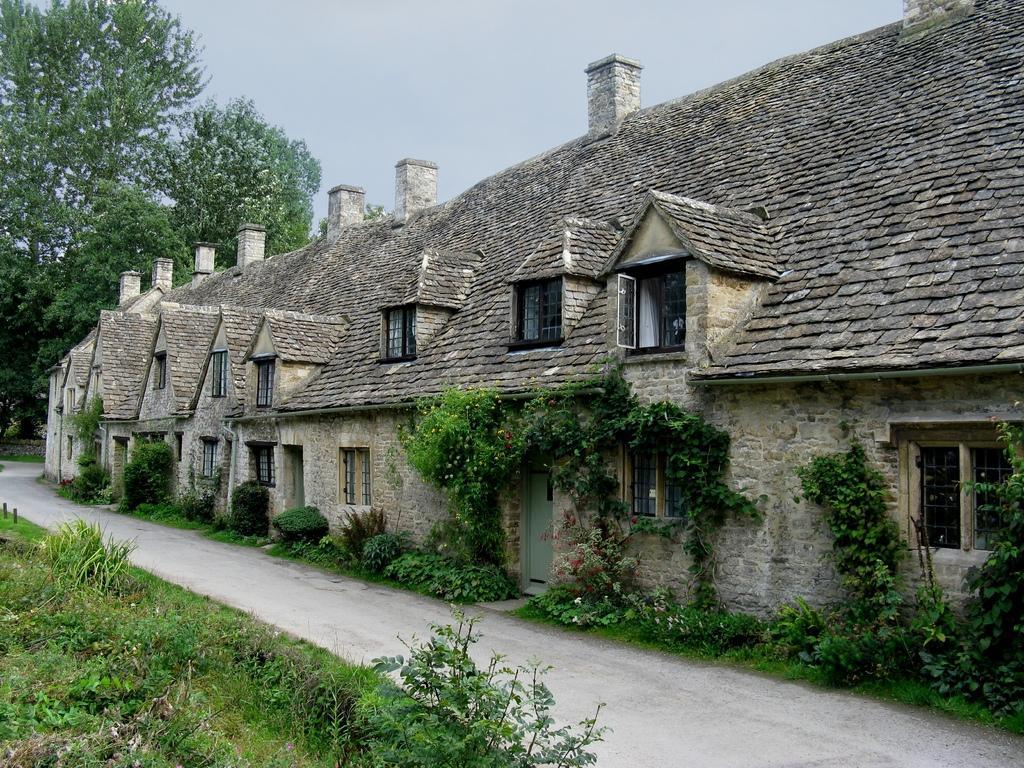How would you summarize this image in a sentence or two? In this image on the left side I can see the grass. I can see the road. On the right side, I can see the houses. I can see the plants. In the background, I can see the trees and the sky. 